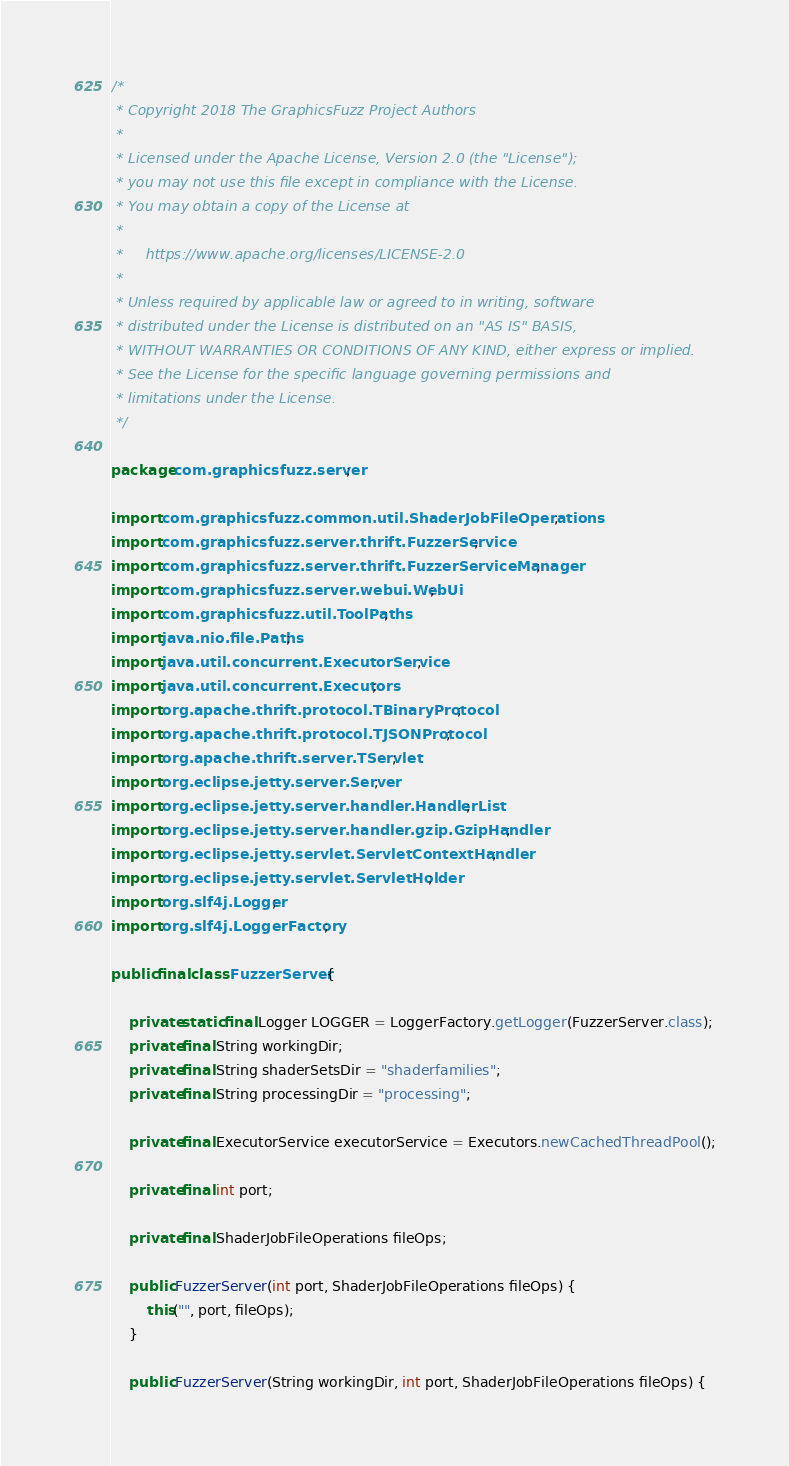Convert code to text. <code><loc_0><loc_0><loc_500><loc_500><_Java_>/*
 * Copyright 2018 The GraphicsFuzz Project Authors
 *
 * Licensed under the Apache License, Version 2.0 (the "License");
 * you may not use this file except in compliance with the License.
 * You may obtain a copy of the License at
 *
 *     https://www.apache.org/licenses/LICENSE-2.0
 *
 * Unless required by applicable law or agreed to in writing, software
 * distributed under the License is distributed on an "AS IS" BASIS,
 * WITHOUT WARRANTIES OR CONDITIONS OF ANY KIND, either express or implied.
 * See the License for the specific language governing permissions and
 * limitations under the License.
 */

package com.graphicsfuzz.server;

import com.graphicsfuzz.common.util.ShaderJobFileOperations;
import com.graphicsfuzz.server.thrift.FuzzerService;
import com.graphicsfuzz.server.thrift.FuzzerServiceManager;
import com.graphicsfuzz.server.webui.WebUi;
import com.graphicsfuzz.util.ToolPaths;
import java.nio.file.Paths;
import java.util.concurrent.ExecutorService;
import java.util.concurrent.Executors;
import org.apache.thrift.protocol.TBinaryProtocol;
import org.apache.thrift.protocol.TJSONProtocol;
import org.apache.thrift.server.TServlet;
import org.eclipse.jetty.server.Server;
import org.eclipse.jetty.server.handler.HandlerList;
import org.eclipse.jetty.server.handler.gzip.GzipHandler;
import org.eclipse.jetty.servlet.ServletContextHandler;
import org.eclipse.jetty.servlet.ServletHolder;
import org.slf4j.Logger;
import org.slf4j.LoggerFactory;

public final class FuzzerServer {

    private static final Logger LOGGER = LoggerFactory.getLogger(FuzzerServer.class);
    private final String workingDir;
    private final String shaderSetsDir = "shaderfamilies";
    private final String processingDir = "processing";

    private final ExecutorService executorService = Executors.newCachedThreadPool();

    private final int port;

    private final ShaderJobFileOperations fileOps;

    public FuzzerServer(int port, ShaderJobFileOperations fileOps) {
        this("", port, fileOps);
    }

    public FuzzerServer(String workingDir, int port, ShaderJobFileOperations fileOps) {</code> 